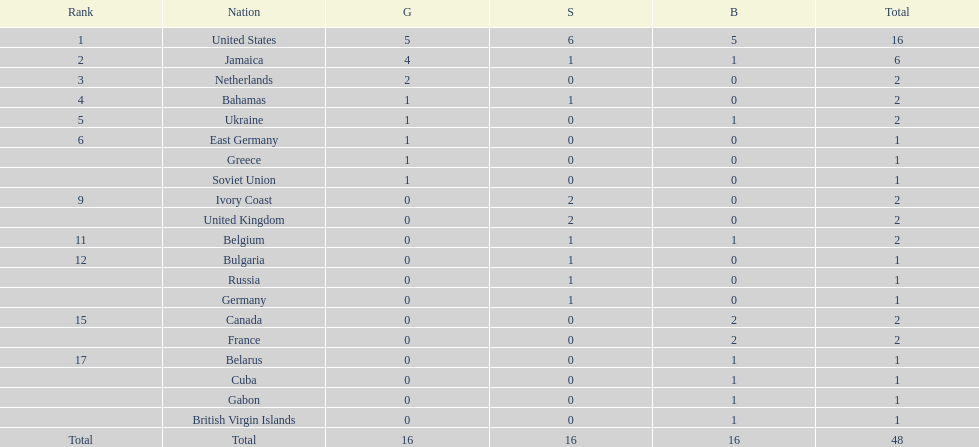What number of nations received 1 medal? 10. Would you mind parsing the complete table? {'header': ['Rank', 'Nation', 'G', 'S', 'B', 'Total'], 'rows': [['1', 'United States', '5', '6', '5', '16'], ['2', 'Jamaica', '4', '1', '1', '6'], ['3', 'Netherlands', '2', '0', '0', '2'], ['4', 'Bahamas', '1', '1', '0', '2'], ['5', 'Ukraine', '1', '0', '1', '2'], ['6', 'East Germany', '1', '0', '0', '1'], ['', 'Greece', '1', '0', '0', '1'], ['', 'Soviet Union', '1', '0', '0', '1'], ['9', 'Ivory Coast', '0', '2', '0', '2'], ['', 'United Kingdom', '0', '2', '0', '2'], ['11', 'Belgium', '0', '1', '1', '2'], ['12', 'Bulgaria', '0', '1', '0', '1'], ['', 'Russia', '0', '1', '0', '1'], ['', 'Germany', '0', '1', '0', '1'], ['15', 'Canada', '0', '0', '2', '2'], ['', 'France', '0', '0', '2', '2'], ['17', 'Belarus', '0', '0', '1', '1'], ['', 'Cuba', '0', '0', '1', '1'], ['', 'Gabon', '0', '0', '1', '1'], ['', 'British Virgin Islands', '0', '0', '1', '1'], ['Total', 'Total', '16', '16', '16', '48']]} 